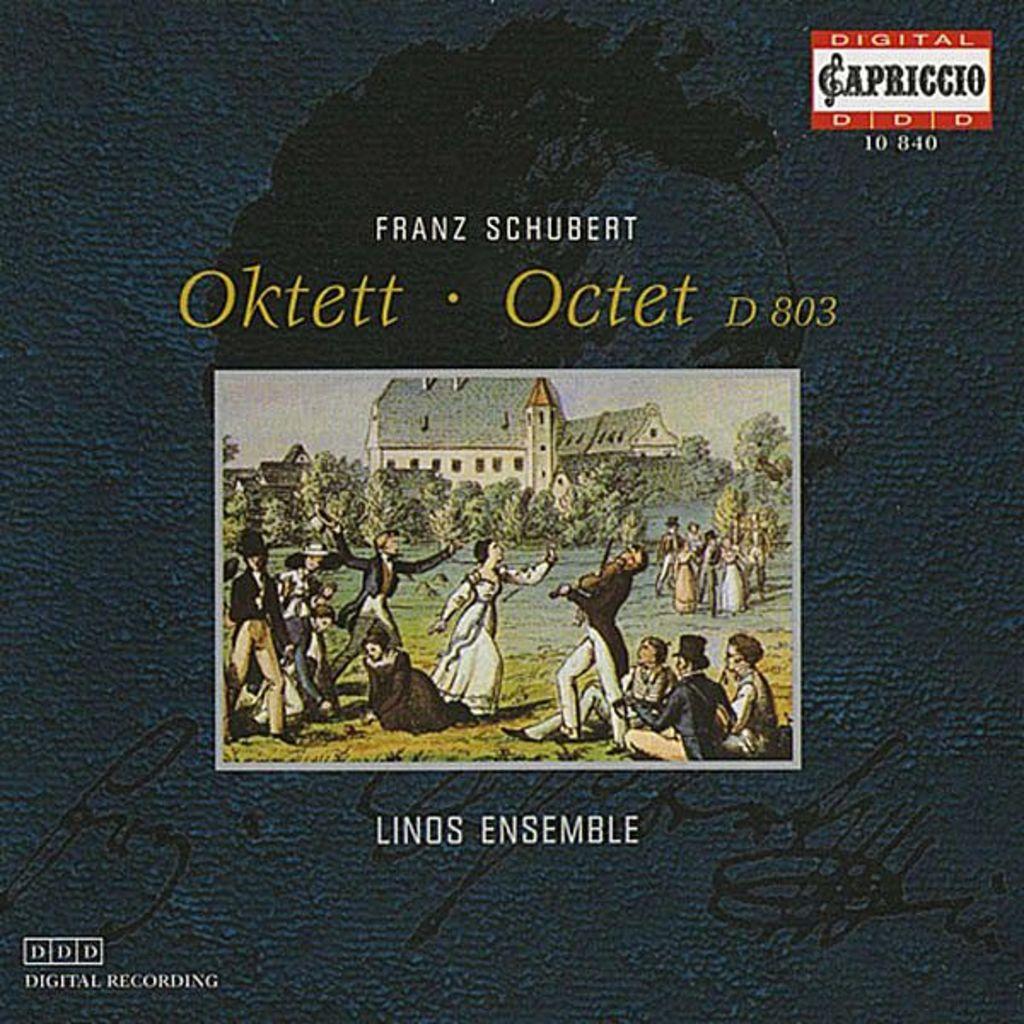What kind of recording is this?
Offer a terse response. Digital. What 3 numbers come after "d"?
Make the answer very short. 803. 